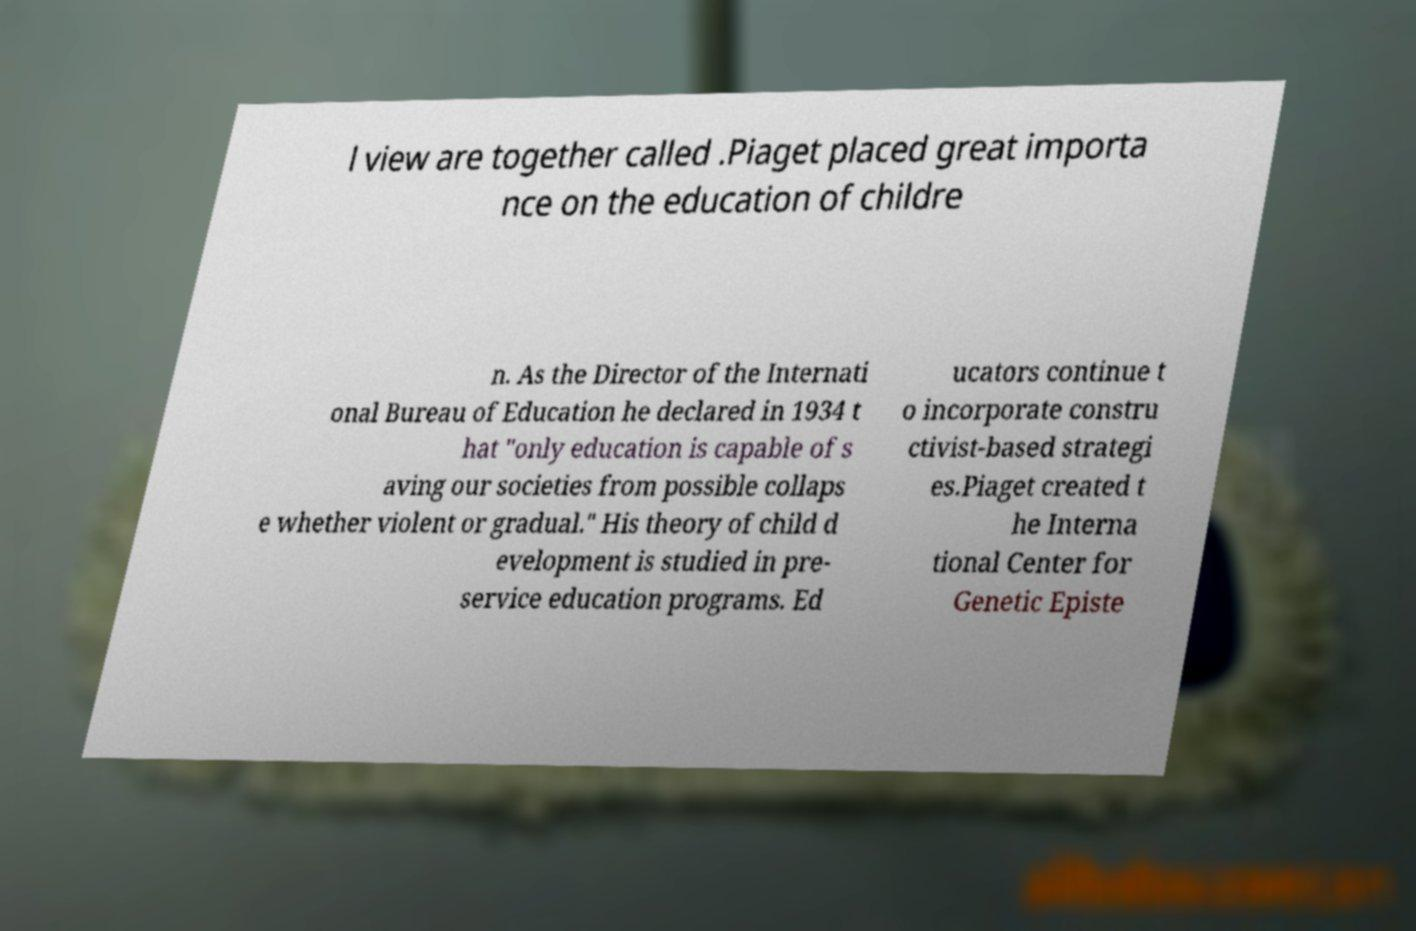Can you read and provide the text displayed in the image?This photo seems to have some interesting text. Can you extract and type it out for me? l view are together called .Piaget placed great importa nce on the education of childre n. As the Director of the Internati onal Bureau of Education he declared in 1934 t hat "only education is capable of s aving our societies from possible collaps e whether violent or gradual." His theory of child d evelopment is studied in pre- service education programs. Ed ucators continue t o incorporate constru ctivist-based strategi es.Piaget created t he Interna tional Center for Genetic Episte 